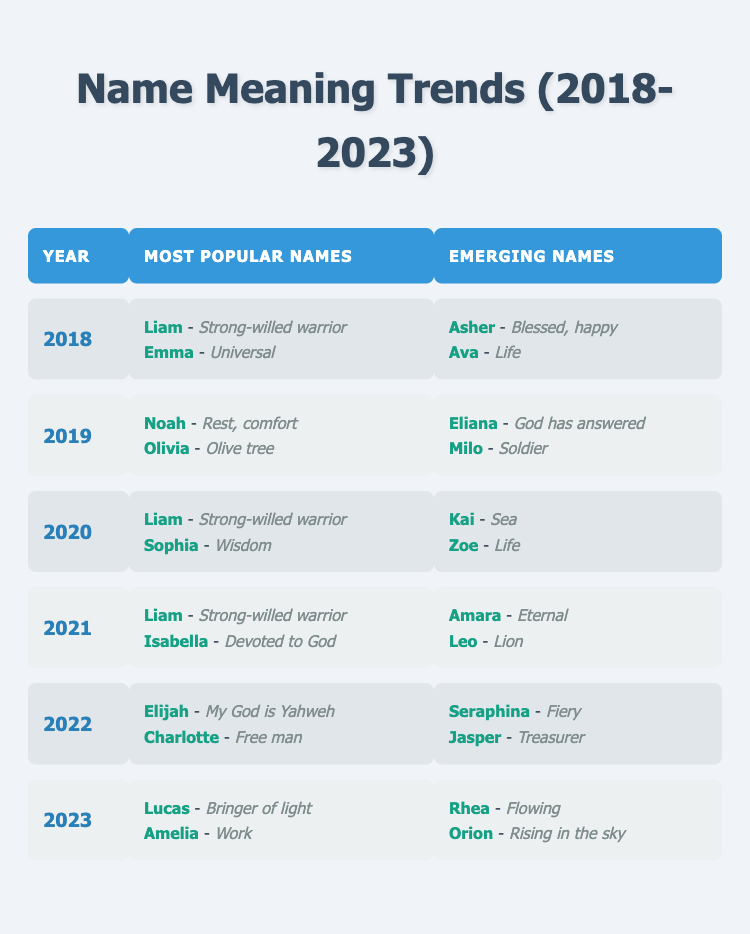What were the most popular names in 2020? According to the table, the most popular names in 2020 were Liam, which means "Strong-willed warrior," and Sophia, which means "Wisdom."
Answer: Liam and Sophia Which emerging name had the meaning "Life" in 2018? Referring to the table, the emerging name that had the meaning "Life" in 2018 was Ava.
Answer: Ava How many years did Liam appear as a most popular name from 2018 to 2023? By looking at the table, Liam appears as a most popular name in 2018, 2020, and 2021. This makes it a total of 3 years.
Answer: 3 years Did any emerging names in 2022 mean "Fiery"? The table shows that in 2022, Seraphina was an emerging name, and its meaning is "Fiery." Therefore, the answer is yes.
Answer: Yes What is the difference in the number of emerging names listed from 2019 to 2021? In both 2019 and 2021, the table shows that there were 2 emerging names each year. Therefore, the difference in the number of emerging names is 0.
Answer: 0 Which name meaning "Rising in the sky" is listed as an emerging name in 2023? The table states that Orion is the emerging name in 2023 that means "Rising in the sky."
Answer: Orion What were the most popular names in 2021, and what do they mean? The most popular names in 2021 were Liam, meaning "Strong-willed warrior," and Isabella, meaning "Devoted to God."
Answer: Liam and Isabella What are the meanings of the two most popular names in 2022? According to the table, the meanings in 2022 are "My God is Yahweh" for Elijah and "Free man" for Charlotte.
Answer: My God is Yahweh and Free man How many times did the name "Ava" appear as an emerging name from 2018 to 2023? Ava is listed as an emerging name only in 2018, so it appears only once during this period.
Answer: 1 time 